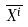<formula> <loc_0><loc_0><loc_500><loc_500>\overline { X ^ { i } }</formula> 